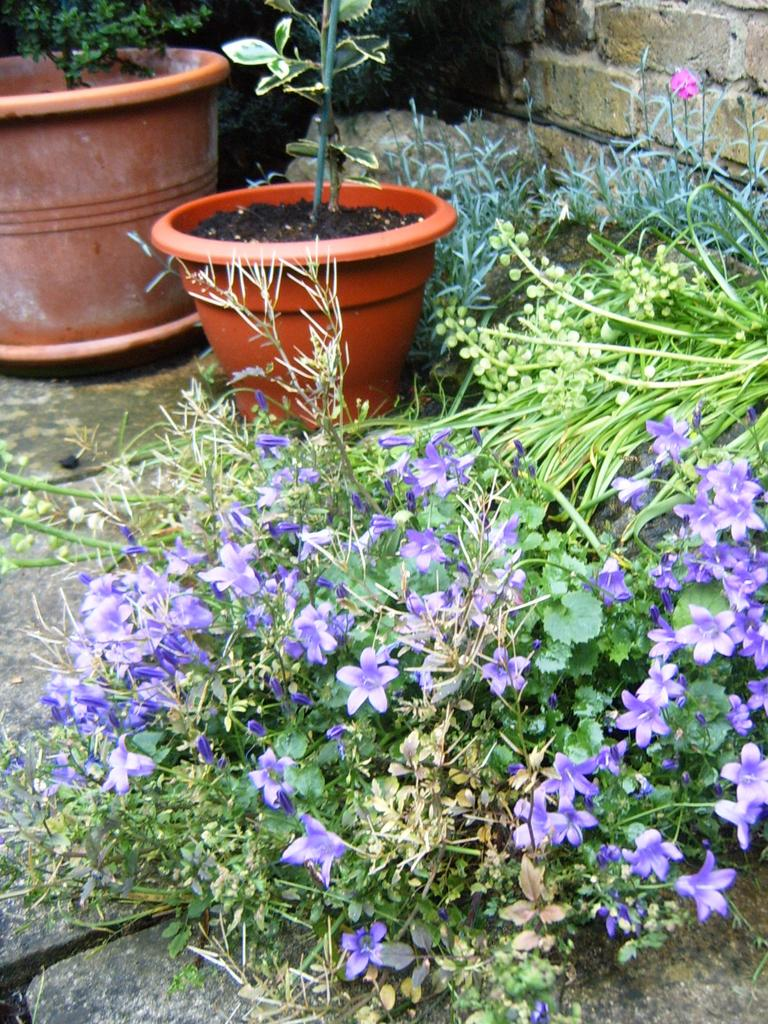What type of containers are present in the image? There are flower pots in the image. What is growing in the flower pots and elsewhere in the image? There are plants and flowers in the image. What type of ground cover can be seen in the image? There is grass in the image. What type of structure is visible in the background of the image? There is a brick wall in the image. What type of terrain is visible in the image? There is land visible in the image. What type of fruit is being baked in the oven in the image? There is no oven or fruit present in the image. 